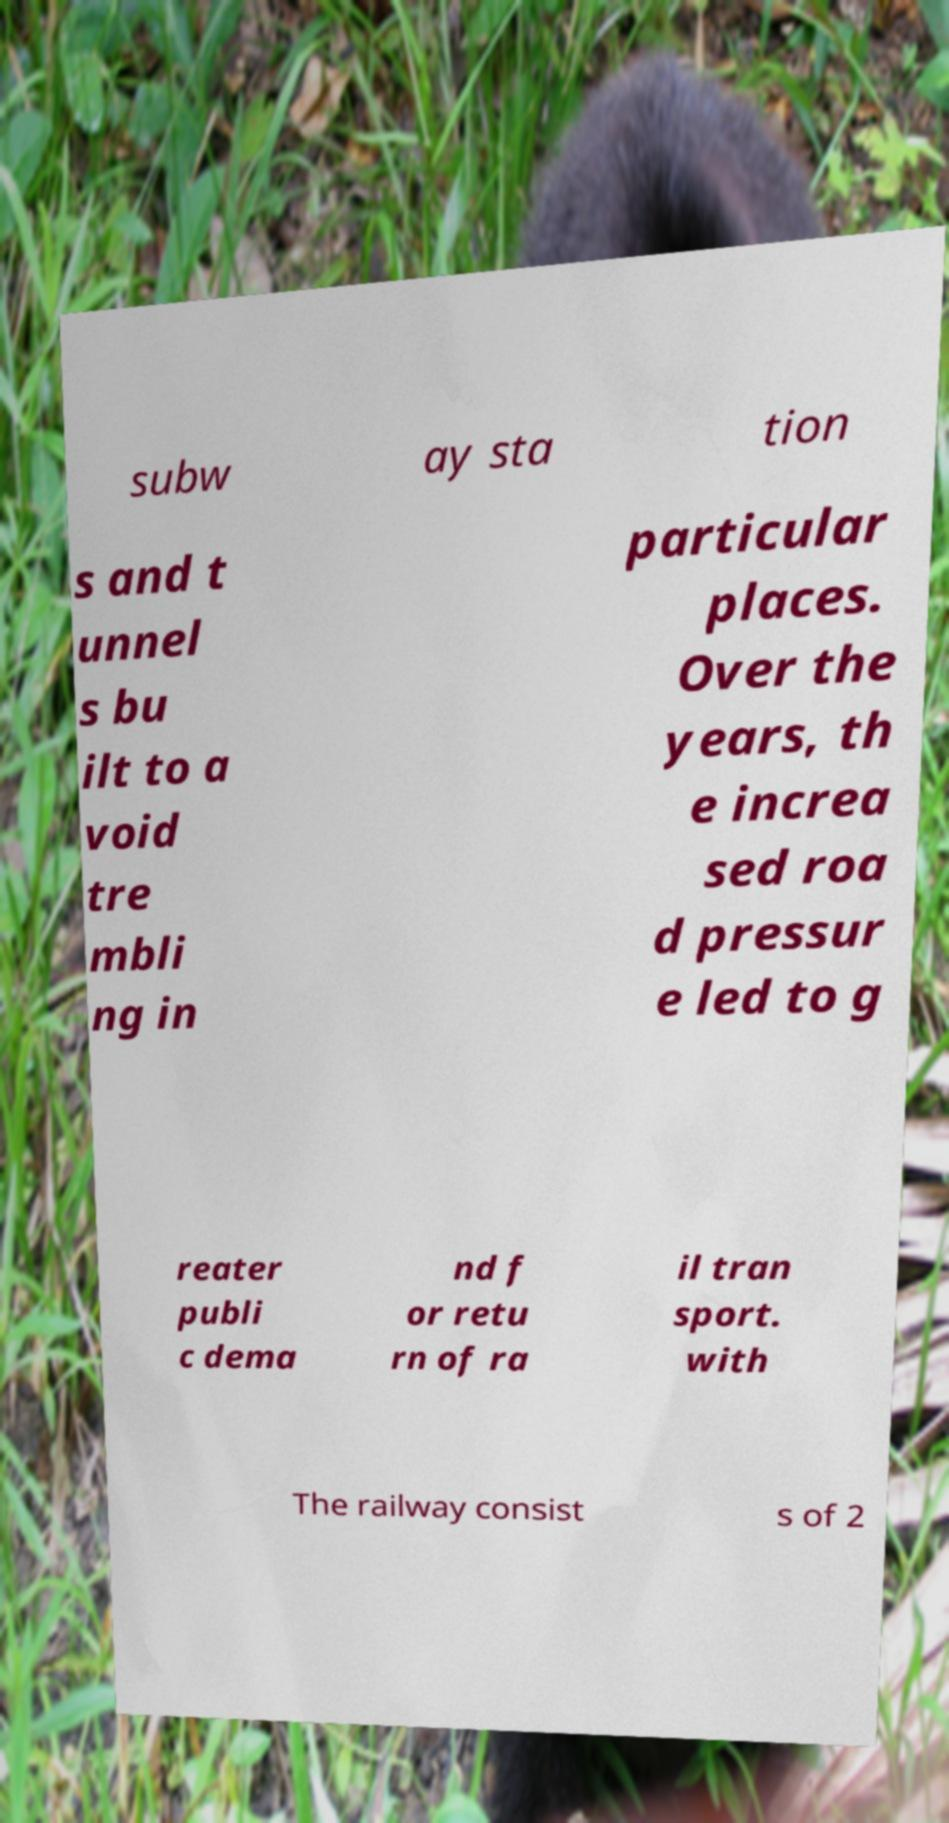For documentation purposes, I need the text within this image transcribed. Could you provide that? subw ay sta tion s and t unnel s bu ilt to a void tre mbli ng in particular places. Over the years, th e increa sed roa d pressur e led to g reater publi c dema nd f or retu rn of ra il tran sport. with The railway consist s of 2 